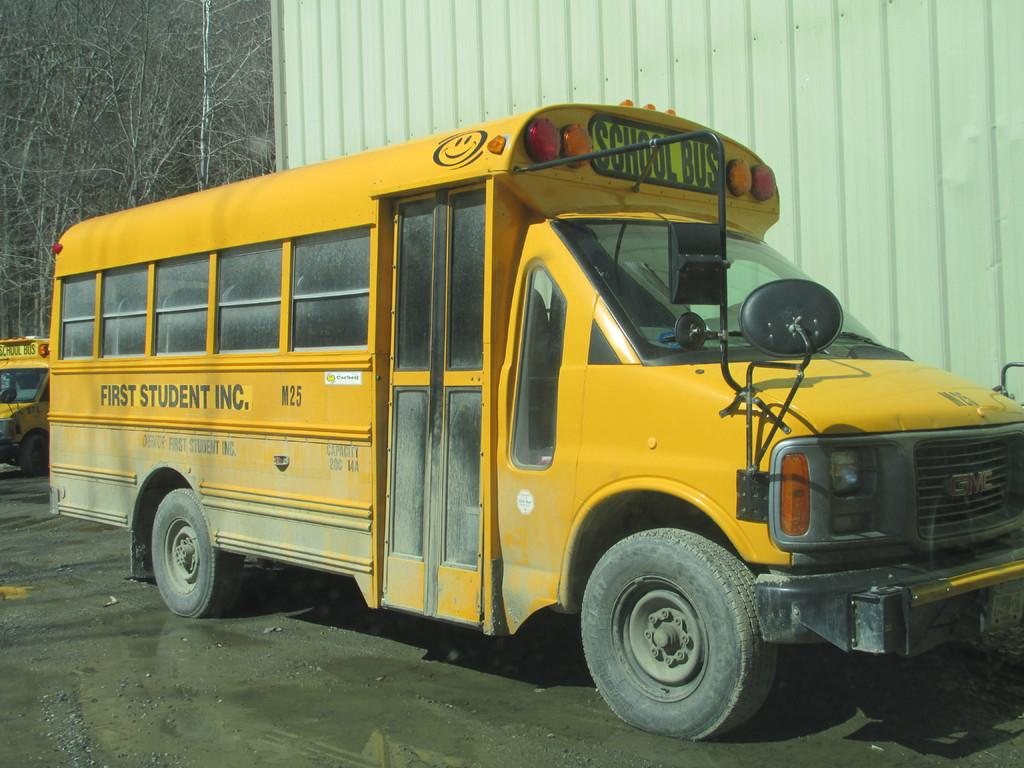What type of objects are present in the image? There are vehicles in the image. What color are the vehicles? The vehicles are yellow in color. Where are the vehicles located in the image? The vehicles are in the front of the image. What can be seen in the background of the image? There are dry trees in the background of the image. What type of knowledge can be gained from the scarecrow in the image? There is no scarecrow present in the image, so no knowledge can be gained from it. 